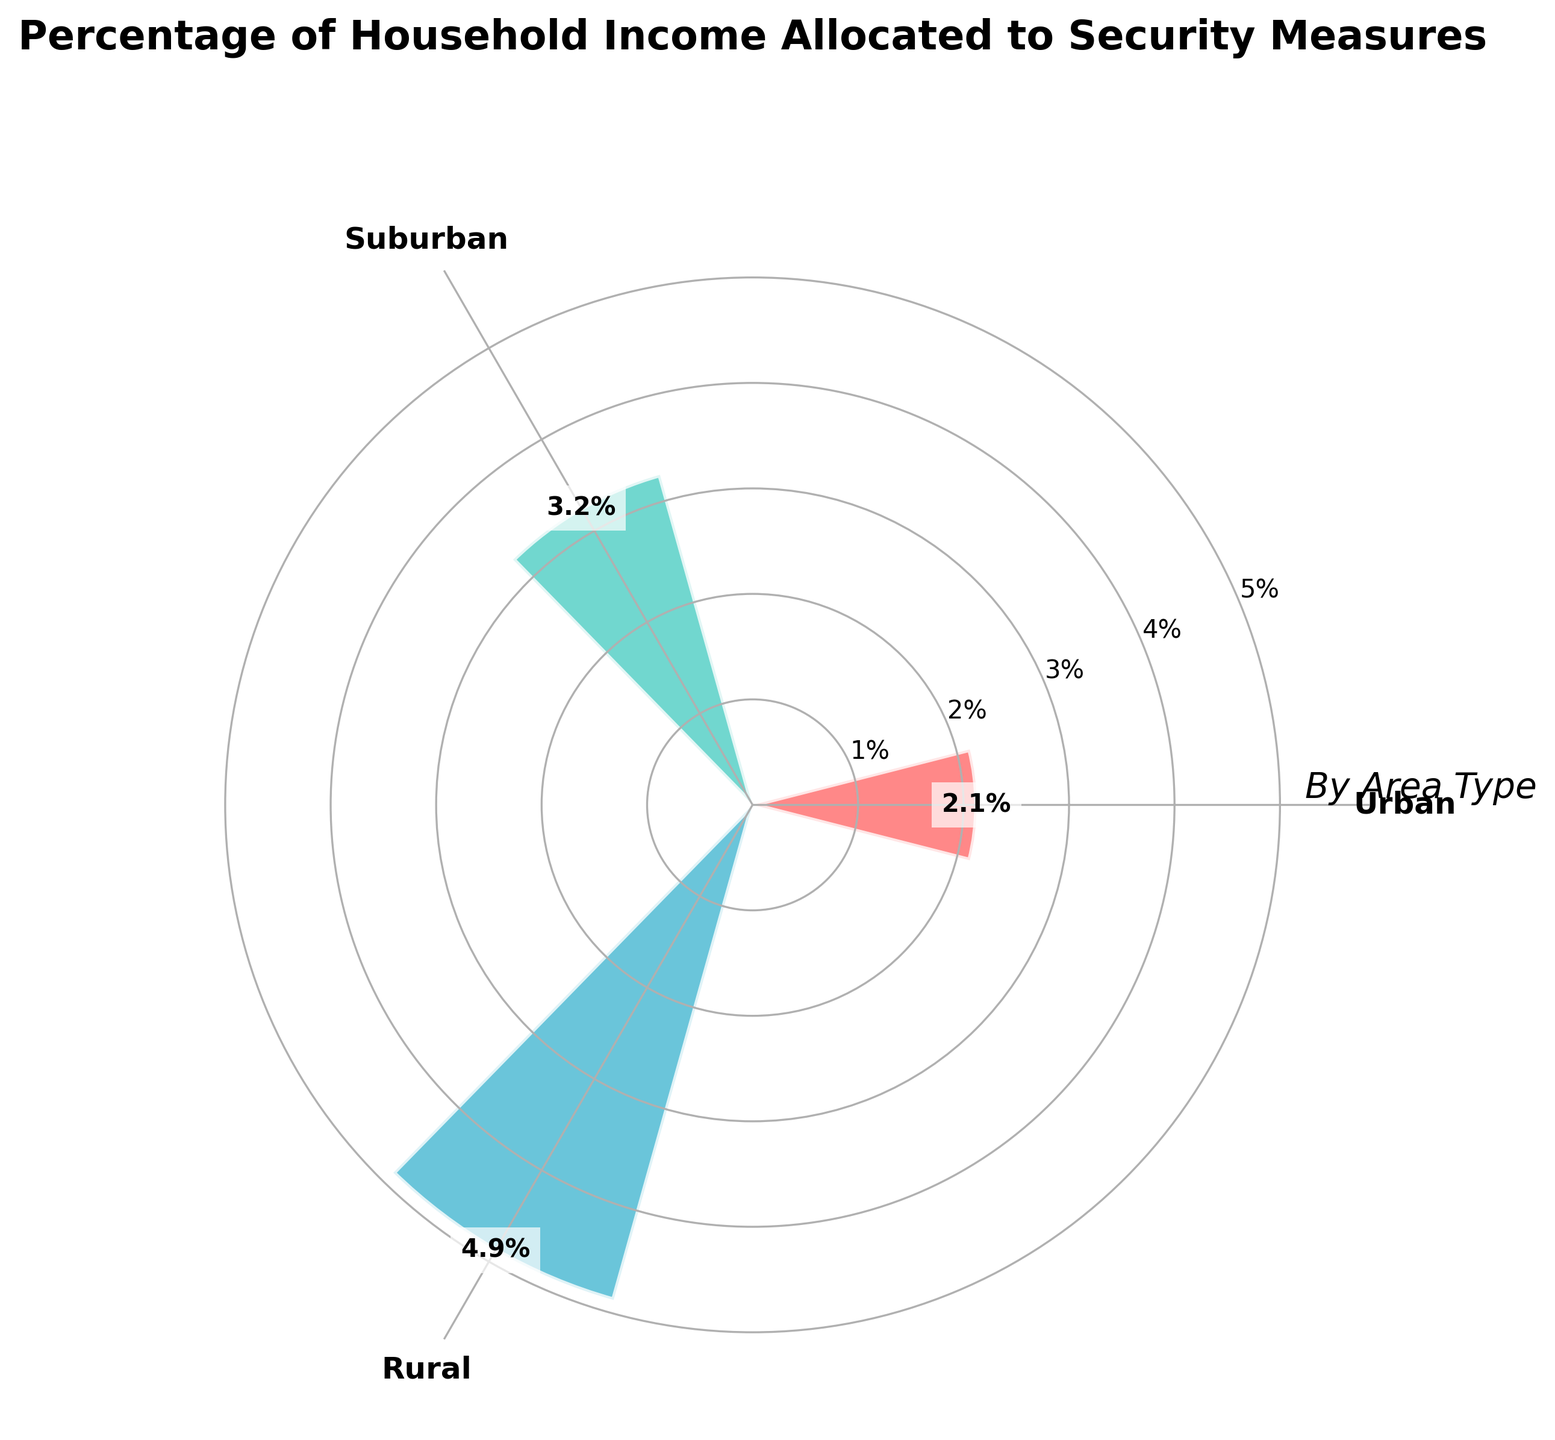What's the title of the chart? The chart's title is located at the top of the visualization. It reads "Percentage of Household Income Allocated to Security Measures."
Answer: Percentage of Household Income Allocated to Security Measures What are the three areas mentioned in the chart? The areas are labeled around the circular axis, and they are Urban, Suburban, and Rural.
Answer: Urban, Suburban, Rural Which area has the highest mean percentage of household income allocated to security measures? The mean percentages are indicated by the length of the radial bars. Urban has the longest bar, indicating the highest mean percentage.
Answer: Urban What is the mean percentage of household income allocated to security measures for suburban areas? The radial bar labeled "Suburban" indicates the mean percentage. The exact value is marked near the end of the bar.
Answer: 3.25% How much more percentage of household income do urban areas allocate to security measures compared to rural areas? Subtract the mean percentage for Rural from Urban. Urban is 4.88% and Rural is 2.125%. The difference is 4.88 - 2.125.
Answer: 2.755% Which color represents the rural areas in the chart? Colors are assigned to each area: Urban is red, Suburban is cyan, and Rural is blue. Hence, Rural is blue.
Answer: blue Rank the areas from highest to lowest based on the percentage of income allocated to security measures. By comparing the lengths of the radial bars, Urban is longest, followed by Suburban, then Rural.
Answer: Urban, Suburban, Rural What is the total mean percentage of household income allocated to security measures across all areas? Add the mean percentages for all areas: Urban (4.88%) + Suburban (3.25%) + Rural (2.125%).
Answer: 10.255% By how much does the mean percentage of income allocated to security in urban areas exceed the average mean across all areas? First, calculate the average mean: (4.88 + 3.25 + 2.125) / 3. Then subtract the average mean from the urban mean: 4.88 - average mean.
Answer: 1.662% What is the radius length of the bar representing the suburban area? The radial bar for Suburban shows a mean percentage of 3.25%, which represents the radius length.
Answer: 3.25% 